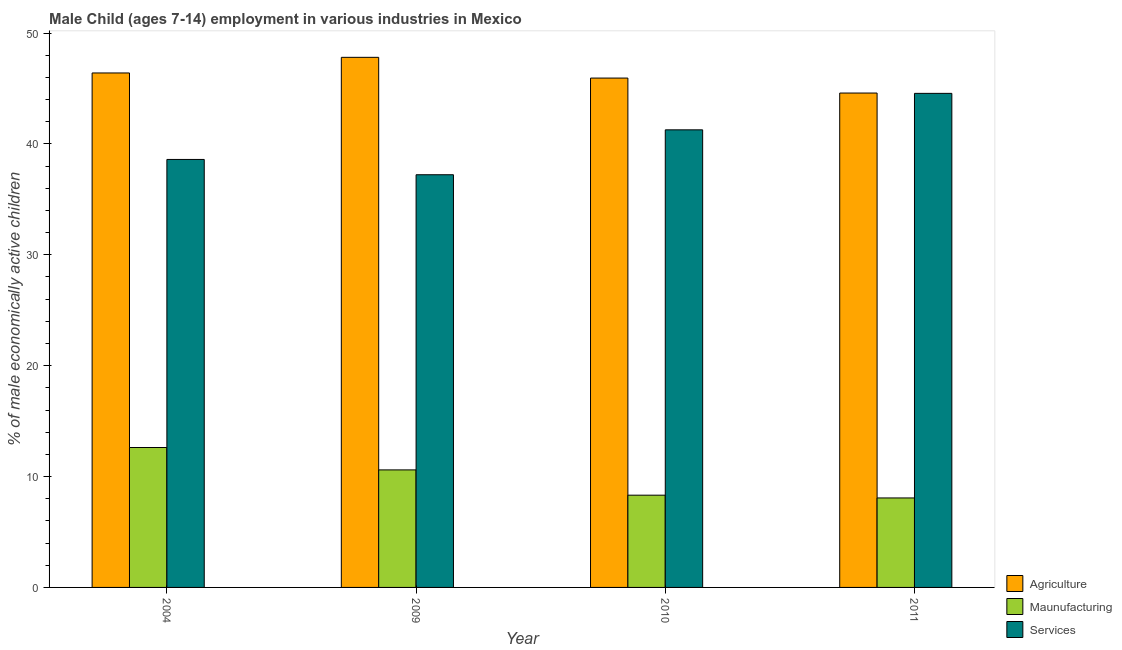How many different coloured bars are there?
Provide a succinct answer. 3. How many groups of bars are there?
Your answer should be compact. 4. Are the number of bars per tick equal to the number of legend labels?
Ensure brevity in your answer.  Yes. Are the number of bars on each tick of the X-axis equal?
Give a very brief answer. Yes. What is the label of the 2nd group of bars from the left?
Offer a very short reply. 2009. What is the percentage of economically active children in services in 2009?
Give a very brief answer. 37.22. Across all years, what is the maximum percentage of economically active children in agriculture?
Your answer should be compact. 47.81. Across all years, what is the minimum percentage of economically active children in services?
Provide a succinct answer. 37.22. In which year was the percentage of economically active children in services maximum?
Offer a terse response. 2011. In which year was the percentage of economically active children in manufacturing minimum?
Give a very brief answer. 2011. What is the total percentage of economically active children in manufacturing in the graph?
Provide a short and direct response. 39.61. What is the difference between the percentage of economically active children in services in 2004 and that in 2010?
Give a very brief answer. -2.67. What is the difference between the percentage of economically active children in agriculture in 2011 and the percentage of economically active children in manufacturing in 2004?
Your response must be concise. -1.81. What is the average percentage of economically active children in services per year?
Make the answer very short. 40.41. In how many years, is the percentage of economically active children in manufacturing greater than 2 %?
Give a very brief answer. 4. What is the ratio of the percentage of economically active children in manufacturing in 2004 to that in 2009?
Keep it short and to the point. 1.19. Is the percentage of economically active children in manufacturing in 2004 less than that in 2010?
Offer a very short reply. No. What is the difference between the highest and the second highest percentage of economically active children in services?
Ensure brevity in your answer.  3.29. What is the difference between the highest and the lowest percentage of economically active children in services?
Offer a very short reply. 7.34. What does the 2nd bar from the left in 2004 represents?
Offer a terse response. Maunufacturing. What does the 3rd bar from the right in 2011 represents?
Provide a short and direct response. Agriculture. Is it the case that in every year, the sum of the percentage of economically active children in agriculture and percentage of economically active children in manufacturing is greater than the percentage of economically active children in services?
Keep it short and to the point. Yes. How many bars are there?
Offer a terse response. 12. Are the values on the major ticks of Y-axis written in scientific E-notation?
Your response must be concise. No. Does the graph contain any zero values?
Offer a terse response. No. Does the graph contain grids?
Ensure brevity in your answer.  No. How many legend labels are there?
Give a very brief answer. 3. What is the title of the graph?
Make the answer very short. Male Child (ages 7-14) employment in various industries in Mexico. Does "Resident buildings and public services" appear as one of the legend labels in the graph?
Your answer should be very brief. No. What is the label or title of the X-axis?
Give a very brief answer. Year. What is the label or title of the Y-axis?
Offer a terse response. % of male economically active children. What is the % of male economically active children of Agriculture in 2004?
Your response must be concise. 46.4. What is the % of male economically active children in Maunufacturing in 2004?
Provide a short and direct response. 12.62. What is the % of male economically active children in Services in 2004?
Provide a succinct answer. 38.6. What is the % of male economically active children in Agriculture in 2009?
Make the answer very short. 47.81. What is the % of male economically active children of Maunufacturing in 2009?
Give a very brief answer. 10.6. What is the % of male economically active children in Services in 2009?
Provide a succinct answer. 37.22. What is the % of male economically active children of Agriculture in 2010?
Keep it short and to the point. 45.94. What is the % of male economically active children in Maunufacturing in 2010?
Provide a short and direct response. 8.32. What is the % of male economically active children in Services in 2010?
Offer a terse response. 41.27. What is the % of male economically active children in Agriculture in 2011?
Ensure brevity in your answer.  44.59. What is the % of male economically active children of Maunufacturing in 2011?
Ensure brevity in your answer.  8.07. What is the % of male economically active children in Services in 2011?
Provide a short and direct response. 44.56. Across all years, what is the maximum % of male economically active children of Agriculture?
Your answer should be compact. 47.81. Across all years, what is the maximum % of male economically active children of Maunufacturing?
Provide a short and direct response. 12.62. Across all years, what is the maximum % of male economically active children in Services?
Make the answer very short. 44.56. Across all years, what is the minimum % of male economically active children in Agriculture?
Ensure brevity in your answer.  44.59. Across all years, what is the minimum % of male economically active children in Maunufacturing?
Offer a very short reply. 8.07. Across all years, what is the minimum % of male economically active children in Services?
Your answer should be compact. 37.22. What is the total % of male economically active children in Agriculture in the graph?
Keep it short and to the point. 184.74. What is the total % of male economically active children in Maunufacturing in the graph?
Offer a very short reply. 39.61. What is the total % of male economically active children in Services in the graph?
Your response must be concise. 161.65. What is the difference between the % of male economically active children in Agriculture in 2004 and that in 2009?
Ensure brevity in your answer.  -1.41. What is the difference between the % of male economically active children in Maunufacturing in 2004 and that in 2009?
Offer a very short reply. 2.02. What is the difference between the % of male economically active children of Services in 2004 and that in 2009?
Provide a succinct answer. 1.38. What is the difference between the % of male economically active children in Agriculture in 2004 and that in 2010?
Ensure brevity in your answer.  0.46. What is the difference between the % of male economically active children in Maunufacturing in 2004 and that in 2010?
Offer a terse response. 4.3. What is the difference between the % of male economically active children of Services in 2004 and that in 2010?
Give a very brief answer. -2.67. What is the difference between the % of male economically active children in Agriculture in 2004 and that in 2011?
Provide a succinct answer. 1.81. What is the difference between the % of male economically active children of Maunufacturing in 2004 and that in 2011?
Offer a very short reply. 4.55. What is the difference between the % of male economically active children in Services in 2004 and that in 2011?
Keep it short and to the point. -5.96. What is the difference between the % of male economically active children of Agriculture in 2009 and that in 2010?
Your answer should be very brief. 1.87. What is the difference between the % of male economically active children of Maunufacturing in 2009 and that in 2010?
Give a very brief answer. 2.28. What is the difference between the % of male economically active children in Services in 2009 and that in 2010?
Your answer should be very brief. -4.05. What is the difference between the % of male economically active children in Agriculture in 2009 and that in 2011?
Give a very brief answer. 3.22. What is the difference between the % of male economically active children in Maunufacturing in 2009 and that in 2011?
Ensure brevity in your answer.  2.53. What is the difference between the % of male economically active children of Services in 2009 and that in 2011?
Offer a terse response. -7.34. What is the difference between the % of male economically active children in Agriculture in 2010 and that in 2011?
Give a very brief answer. 1.35. What is the difference between the % of male economically active children in Maunufacturing in 2010 and that in 2011?
Your answer should be compact. 0.25. What is the difference between the % of male economically active children in Services in 2010 and that in 2011?
Provide a short and direct response. -3.29. What is the difference between the % of male economically active children of Agriculture in 2004 and the % of male economically active children of Maunufacturing in 2009?
Provide a short and direct response. 35.8. What is the difference between the % of male economically active children in Agriculture in 2004 and the % of male economically active children in Services in 2009?
Your answer should be very brief. 9.18. What is the difference between the % of male economically active children of Maunufacturing in 2004 and the % of male economically active children of Services in 2009?
Your answer should be compact. -24.6. What is the difference between the % of male economically active children in Agriculture in 2004 and the % of male economically active children in Maunufacturing in 2010?
Your answer should be compact. 38.08. What is the difference between the % of male economically active children in Agriculture in 2004 and the % of male economically active children in Services in 2010?
Keep it short and to the point. 5.13. What is the difference between the % of male economically active children in Maunufacturing in 2004 and the % of male economically active children in Services in 2010?
Your response must be concise. -28.65. What is the difference between the % of male economically active children in Agriculture in 2004 and the % of male economically active children in Maunufacturing in 2011?
Provide a succinct answer. 38.33. What is the difference between the % of male economically active children of Agriculture in 2004 and the % of male economically active children of Services in 2011?
Offer a very short reply. 1.84. What is the difference between the % of male economically active children in Maunufacturing in 2004 and the % of male economically active children in Services in 2011?
Your answer should be very brief. -31.94. What is the difference between the % of male economically active children of Agriculture in 2009 and the % of male economically active children of Maunufacturing in 2010?
Ensure brevity in your answer.  39.49. What is the difference between the % of male economically active children in Agriculture in 2009 and the % of male economically active children in Services in 2010?
Offer a terse response. 6.54. What is the difference between the % of male economically active children in Maunufacturing in 2009 and the % of male economically active children in Services in 2010?
Your response must be concise. -30.67. What is the difference between the % of male economically active children in Agriculture in 2009 and the % of male economically active children in Maunufacturing in 2011?
Your answer should be compact. 39.74. What is the difference between the % of male economically active children of Maunufacturing in 2009 and the % of male economically active children of Services in 2011?
Your response must be concise. -33.96. What is the difference between the % of male economically active children of Agriculture in 2010 and the % of male economically active children of Maunufacturing in 2011?
Your answer should be very brief. 37.87. What is the difference between the % of male economically active children in Agriculture in 2010 and the % of male economically active children in Services in 2011?
Your response must be concise. 1.38. What is the difference between the % of male economically active children in Maunufacturing in 2010 and the % of male economically active children in Services in 2011?
Give a very brief answer. -36.24. What is the average % of male economically active children of Agriculture per year?
Provide a succinct answer. 46.19. What is the average % of male economically active children in Maunufacturing per year?
Make the answer very short. 9.9. What is the average % of male economically active children of Services per year?
Offer a very short reply. 40.41. In the year 2004, what is the difference between the % of male economically active children in Agriculture and % of male economically active children in Maunufacturing?
Your response must be concise. 33.78. In the year 2004, what is the difference between the % of male economically active children in Agriculture and % of male economically active children in Services?
Give a very brief answer. 7.8. In the year 2004, what is the difference between the % of male economically active children of Maunufacturing and % of male economically active children of Services?
Provide a short and direct response. -25.98. In the year 2009, what is the difference between the % of male economically active children of Agriculture and % of male economically active children of Maunufacturing?
Offer a very short reply. 37.21. In the year 2009, what is the difference between the % of male economically active children of Agriculture and % of male economically active children of Services?
Keep it short and to the point. 10.59. In the year 2009, what is the difference between the % of male economically active children in Maunufacturing and % of male economically active children in Services?
Provide a succinct answer. -26.62. In the year 2010, what is the difference between the % of male economically active children of Agriculture and % of male economically active children of Maunufacturing?
Offer a very short reply. 37.62. In the year 2010, what is the difference between the % of male economically active children of Agriculture and % of male economically active children of Services?
Provide a succinct answer. 4.67. In the year 2010, what is the difference between the % of male economically active children in Maunufacturing and % of male economically active children in Services?
Offer a terse response. -32.95. In the year 2011, what is the difference between the % of male economically active children of Agriculture and % of male economically active children of Maunufacturing?
Provide a succinct answer. 36.52. In the year 2011, what is the difference between the % of male economically active children of Maunufacturing and % of male economically active children of Services?
Provide a succinct answer. -36.49. What is the ratio of the % of male economically active children in Agriculture in 2004 to that in 2009?
Keep it short and to the point. 0.97. What is the ratio of the % of male economically active children of Maunufacturing in 2004 to that in 2009?
Provide a succinct answer. 1.19. What is the ratio of the % of male economically active children in Services in 2004 to that in 2009?
Offer a very short reply. 1.04. What is the ratio of the % of male economically active children in Maunufacturing in 2004 to that in 2010?
Offer a very short reply. 1.52. What is the ratio of the % of male economically active children of Services in 2004 to that in 2010?
Keep it short and to the point. 0.94. What is the ratio of the % of male economically active children in Agriculture in 2004 to that in 2011?
Ensure brevity in your answer.  1.04. What is the ratio of the % of male economically active children in Maunufacturing in 2004 to that in 2011?
Keep it short and to the point. 1.56. What is the ratio of the % of male economically active children of Services in 2004 to that in 2011?
Offer a terse response. 0.87. What is the ratio of the % of male economically active children of Agriculture in 2009 to that in 2010?
Keep it short and to the point. 1.04. What is the ratio of the % of male economically active children in Maunufacturing in 2009 to that in 2010?
Your answer should be compact. 1.27. What is the ratio of the % of male economically active children in Services in 2009 to that in 2010?
Keep it short and to the point. 0.9. What is the ratio of the % of male economically active children in Agriculture in 2009 to that in 2011?
Give a very brief answer. 1.07. What is the ratio of the % of male economically active children of Maunufacturing in 2009 to that in 2011?
Give a very brief answer. 1.31. What is the ratio of the % of male economically active children of Services in 2009 to that in 2011?
Ensure brevity in your answer.  0.84. What is the ratio of the % of male economically active children of Agriculture in 2010 to that in 2011?
Give a very brief answer. 1.03. What is the ratio of the % of male economically active children of Maunufacturing in 2010 to that in 2011?
Ensure brevity in your answer.  1.03. What is the ratio of the % of male economically active children of Services in 2010 to that in 2011?
Offer a very short reply. 0.93. What is the difference between the highest and the second highest % of male economically active children in Agriculture?
Offer a very short reply. 1.41. What is the difference between the highest and the second highest % of male economically active children in Maunufacturing?
Your response must be concise. 2.02. What is the difference between the highest and the second highest % of male economically active children of Services?
Keep it short and to the point. 3.29. What is the difference between the highest and the lowest % of male economically active children of Agriculture?
Your response must be concise. 3.22. What is the difference between the highest and the lowest % of male economically active children of Maunufacturing?
Provide a succinct answer. 4.55. What is the difference between the highest and the lowest % of male economically active children of Services?
Ensure brevity in your answer.  7.34. 